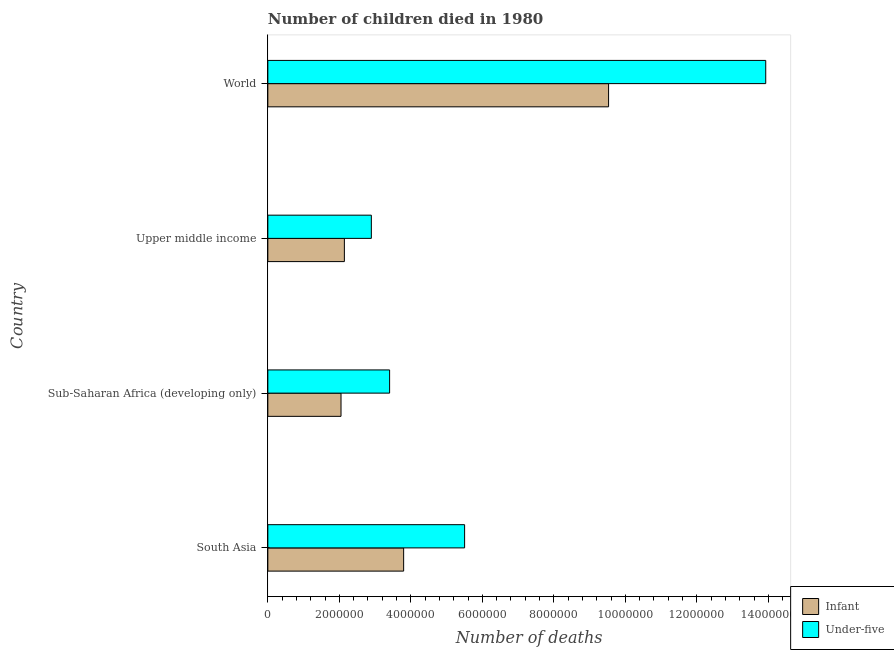How many different coloured bars are there?
Your response must be concise. 2. How many groups of bars are there?
Your answer should be compact. 4. Are the number of bars per tick equal to the number of legend labels?
Provide a short and direct response. Yes. Are the number of bars on each tick of the Y-axis equal?
Make the answer very short. Yes. How many bars are there on the 4th tick from the top?
Your answer should be very brief. 2. What is the label of the 1st group of bars from the top?
Offer a very short reply. World. In how many cases, is the number of bars for a given country not equal to the number of legend labels?
Provide a short and direct response. 0. What is the number of infant deaths in Sub-Saharan Africa (developing only)?
Offer a very short reply. 2.05e+06. Across all countries, what is the maximum number of infant deaths?
Ensure brevity in your answer.  9.53e+06. Across all countries, what is the minimum number of under-five deaths?
Provide a succinct answer. 2.90e+06. In which country was the number of infant deaths maximum?
Provide a succinct answer. World. In which country was the number of infant deaths minimum?
Provide a short and direct response. Sub-Saharan Africa (developing only). What is the total number of under-five deaths in the graph?
Ensure brevity in your answer.  2.57e+07. What is the difference between the number of under-five deaths in South Asia and that in World?
Keep it short and to the point. -8.42e+06. What is the difference between the number of under-five deaths in World and the number of infant deaths in South Asia?
Your answer should be compact. 1.01e+07. What is the average number of infant deaths per country?
Give a very brief answer. 4.38e+06. What is the difference between the number of infant deaths and number of under-five deaths in Sub-Saharan Africa (developing only)?
Provide a succinct answer. -1.36e+06. What is the ratio of the number of infant deaths in Sub-Saharan Africa (developing only) to that in World?
Ensure brevity in your answer.  0.21. Is the number of infant deaths in Sub-Saharan Africa (developing only) less than that in World?
Offer a terse response. Yes. Is the difference between the number of infant deaths in South Asia and World greater than the difference between the number of under-five deaths in South Asia and World?
Provide a succinct answer. Yes. What is the difference between the highest and the second highest number of under-five deaths?
Provide a succinct answer. 8.42e+06. What is the difference between the highest and the lowest number of under-five deaths?
Ensure brevity in your answer.  1.10e+07. In how many countries, is the number of under-five deaths greater than the average number of under-five deaths taken over all countries?
Your answer should be compact. 1. Is the sum of the number of under-five deaths in Upper middle income and World greater than the maximum number of infant deaths across all countries?
Provide a short and direct response. Yes. What does the 1st bar from the top in World represents?
Ensure brevity in your answer.  Under-five. What does the 1st bar from the bottom in Upper middle income represents?
Your response must be concise. Infant. How many bars are there?
Your answer should be compact. 8. Are all the bars in the graph horizontal?
Give a very brief answer. Yes. How many countries are there in the graph?
Provide a succinct answer. 4. What is the difference between two consecutive major ticks on the X-axis?
Give a very brief answer. 2.00e+06. Are the values on the major ticks of X-axis written in scientific E-notation?
Provide a succinct answer. No. Where does the legend appear in the graph?
Your response must be concise. Bottom right. How many legend labels are there?
Your answer should be very brief. 2. What is the title of the graph?
Your response must be concise. Number of children died in 1980. Does "Under-five" appear as one of the legend labels in the graph?
Provide a succinct answer. Yes. What is the label or title of the X-axis?
Ensure brevity in your answer.  Number of deaths. What is the Number of deaths in Infant in South Asia?
Ensure brevity in your answer.  3.80e+06. What is the Number of deaths in Under-five in South Asia?
Offer a terse response. 5.50e+06. What is the Number of deaths in Infant in Sub-Saharan Africa (developing only)?
Make the answer very short. 2.05e+06. What is the Number of deaths in Under-five in Sub-Saharan Africa (developing only)?
Keep it short and to the point. 3.41e+06. What is the Number of deaths of Infant in Upper middle income?
Ensure brevity in your answer.  2.14e+06. What is the Number of deaths of Under-five in Upper middle income?
Give a very brief answer. 2.90e+06. What is the Number of deaths in Infant in World?
Your answer should be very brief. 9.53e+06. What is the Number of deaths of Under-five in World?
Provide a succinct answer. 1.39e+07. Across all countries, what is the maximum Number of deaths in Infant?
Make the answer very short. 9.53e+06. Across all countries, what is the maximum Number of deaths of Under-five?
Give a very brief answer. 1.39e+07. Across all countries, what is the minimum Number of deaths of Infant?
Ensure brevity in your answer.  2.05e+06. Across all countries, what is the minimum Number of deaths in Under-five?
Provide a succinct answer. 2.90e+06. What is the total Number of deaths of Infant in the graph?
Make the answer very short. 1.75e+07. What is the total Number of deaths of Under-five in the graph?
Your answer should be very brief. 2.57e+07. What is the difference between the Number of deaths of Infant in South Asia and that in Sub-Saharan Africa (developing only)?
Ensure brevity in your answer.  1.75e+06. What is the difference between the Number of deaths of Under-five in South Asia and that in Sub-Saharan Africa (developing only)?
Make the answer very short. 2.10e+06. What is the difference between the Number of deaths of Infant in South Asia and that in Upper middle income?
Offer a terse response. 1.66e+06. What is the difference between the Number of deaths of Under-five in South Asia and that in Upper middle income?
Your answer should be compact. 2.61e+06. What is the difference between the Number of deaths in Infant in South Asia and that in World?
Keep it short and to the point. -5.73e+06. What is the difference between the Number of deaths in Under-five in South Asia and that in World?
Give a very brief answer. -8.42e+06. What is the difference between the Number of deaths of Infant in Sub-Saharan Africa (developing only) and that in Upper middle income?
Provide a short and direct response. -9.40e+04. What is the difference between the Number of deaths of Under-five in Sub-Saharan Africa (developing only) and that in Upper middle income?
Make the answer very short. 5.11e+05. What is the difference between the Number of deaths of Infant in Sub-Saharan Africa (developing only) and that in World?
Your answer should be very brief. -7.48e+06. What is the difference between the Number of deaths in Under-five in Sub-Saharan Africa (developing only) and that in World?
Provide a short and direct response. -1.05e+07. What is the difference between the Number of deaths of Infant in Upper middle income and that in World?
Provide a short and direct response. -7.39e+06. What is the difference between the Number of deaths of Under-five in Upper middle income and that in World?
Your response must be concise. -1.10e+07. What is the difference between the Number of deaths in Infant in South Asia and the Number of deaths in Under-five in Sub-Saharan Africa (developing only)?
Provide a short and direct response. 3.93e+05. What is the difference between the Number of deaths in Infant in South Asia and the Number of deaths in Under-five in Upper middle income?
Provide a succinct answer. 9.03e+05. What is the difference between the Number of deaths of Infant in South Asia and the Number of deaths of Under-five in World?
Offer a terse response. -1.01e+07. What is the difference between the Number of deaths in Infant in Sub-Saharan Africa (developing only) and the Number of deaths in Under-five in Upper middle income?
Keep it short and to the point. -8.48e+05. What is the difference between the Number of deaths in Infant in Sub-Saharan Africa (developing only) and the Number of deaths in Under-five in World?
Your answer should be compact. -1.19e+07. What is the difference between the Number of deaths of Infant in Upper middle income and the Number of deaths of Under-five in World?
Make the answer very short. -1.18e+07. What is the average Number of deaths of Infant per country?
Offer a terse response. 4.38e+06. What is the average Number of deaths of Under-five per country?
Your answer should be very brief. 6.43e+06. What is the difference between the Number of deaths in Infant and Number of deaths in Under-five in South Asia?
Provide a succinct answer. -1.71e+06. What is the difference between the Number of deaths of Infant and Number of deaths of Under-five in Sub-Saharan Africa (developing only)?
Your response must be concise. -1.36e+06. What is the difference between the Number of deaths in Infant and Number of deaths in Under-five in Upper middle income?
Your response must be concise. -7.54e+05. What is the difference between the Number of deaths in Infant and Number of deaths in Under-five in World?
Keep it short and to the point. -4.40e+06. What is the ratio of the Number of deaths of Infant in South Asia to that in Sub-Saharan Africa (developing only)?
Provide a succinct answer. 1.86. What is the ratio of the Number of deaths in Under-five in South Asia to that in Sub-Saharan Africa (developing only)?
Offer a very short reply. 1.62. What is the ratio of the Number of deaths of Infant in South Asia to that in Upper middle income?
Your answer should be very brief. 1.77. What is the ratio of the Number of deaths in Under-five in South Asia to that in Upper middle income?
Make the answer very short. 1.9. What is the ratio of the Number of deaths of Infant in South Asia to that in World?
Offer a terse response. 0.4. What is the ratio of the Number of deaths in Under-five in South Asia to that in World?
Your response must be concise. 0.4. What is the ratio of the Number of deaths of Infant in Sub-Saharan Africa (developing only) to that in Upper middle income?
Make the answer very short. 0.96. What is the ratio of the Number of deaths of Under-five in Sub-Saharan Africa (developing only) to that in Upper middle income?
Provide a short and direct response. 1.18. What is the ratio of the Number of deaths of Infant in Sub-Saharan Africa (developing only) to that in World?
Offer a terse response. 0.21. What is the ratio of the Number of deaths in Under-five in Sub-Saharan Africa (developing only) to that in World?
Keep it short and to the point. 0.24. What is the ratio of the Number of deaths of Infant in Upper middle income to that in World?
Your answer should be compact. 0.22. What is the ratio of the Number of deaths in Under-five in Upper middle income to that in World?
Your answer should be compact. 0.21. What is the difference between the highest and the second highest Number of deaths in Infant?
Offer a very short reply. 5.73e+06. What is the difference between the highest and the second highest Number of deaths of Under-five?
Ensure brevity in your answer.  8.42e+06. What is the difference between the highest and the lowest Number of deaths of Infant?
Ensure brevity in your answer.  7.48e+06. What is the difference between the highest and the lowest Number of deaths in Under-five?
Make the answer very short. 1.10e+07. 